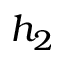<formula> <loc_0><loc_0><loc_500><loc_500>h _ { 2 }</formula> 